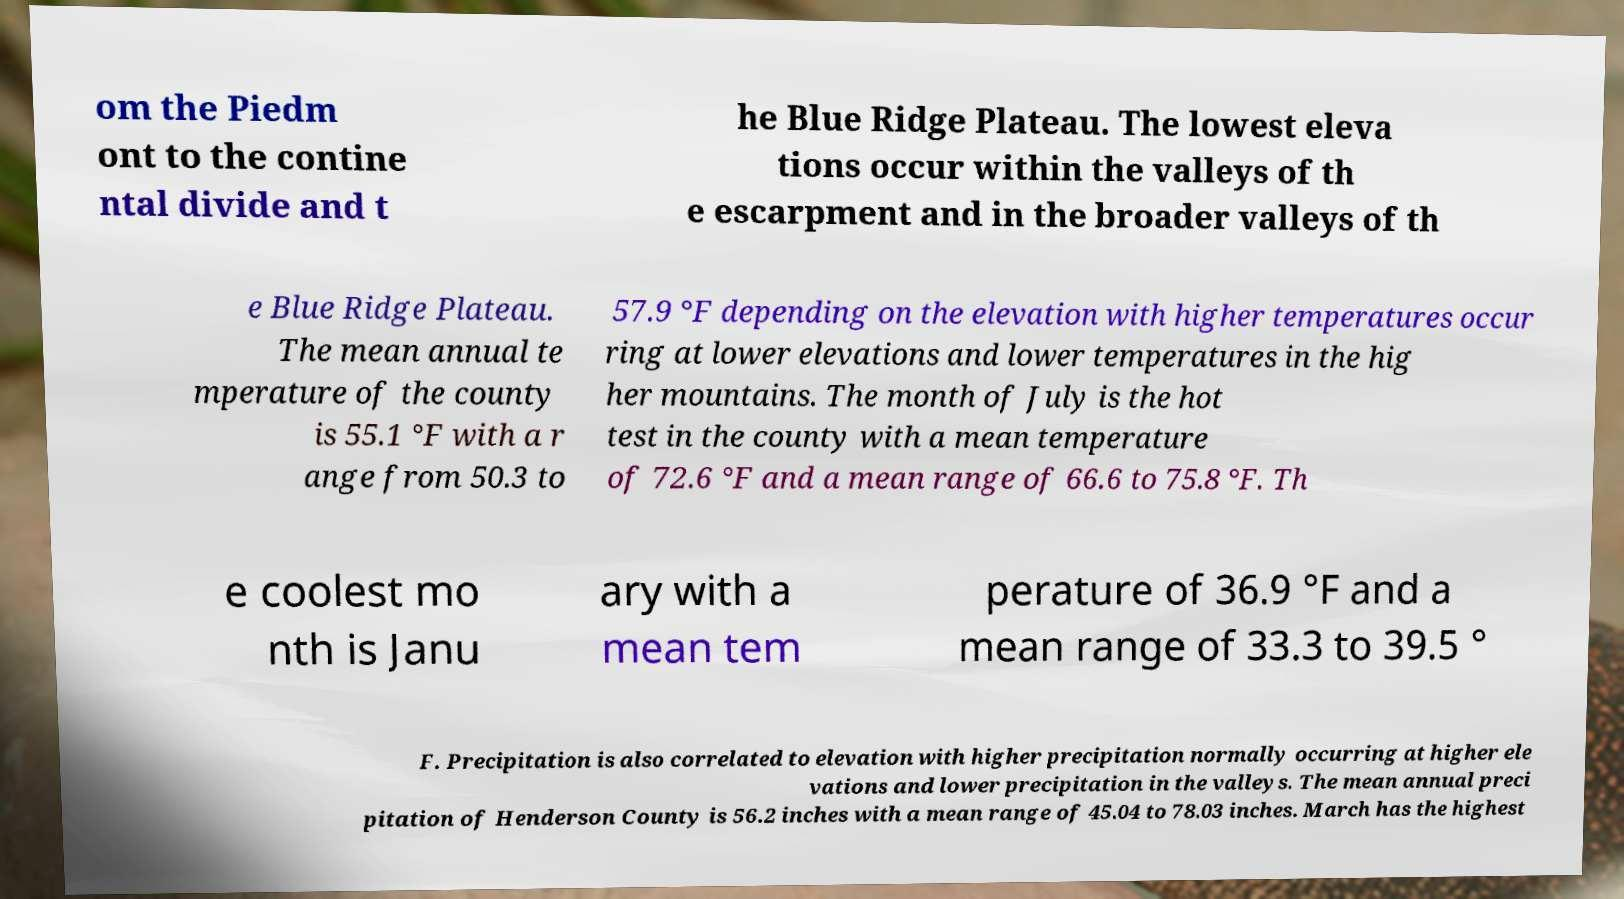Could you assist in decoding the text presented in this image and type it out clearly? om the Piedm ont to the contine ntal divide and t he Blue Ridge Plateau. The lowest eleva tions occur within the valleys of th e escarpment and in the broader valleys of th e Blue Ridge Plateau. The mean annual te mperature of the county is 55.1 °F with a r ange from 50.3 to 57.9 °F depending on the elevation with higher temperatures occur ring at lower elevations and lower temperatures in the hig her mountains. The month of July is the hot test in the county with a mean temperature of 72.6 °F and a mean range of 66.6 to 75.8 °F. Th e coolest mo nth is Janu ary with a mean tem perature of 36.9 °F and a mean range of 33.3 to 39.5 ° F. Precipitation is also correlated to elevation with higher precipitation normally occurring at higher ele vations and lower precipitation in the valleys. The mean annual preci pitation of Henderson County is 56.2 inches with a mean range of 45.04 to 78.03 inches. March has the highest 